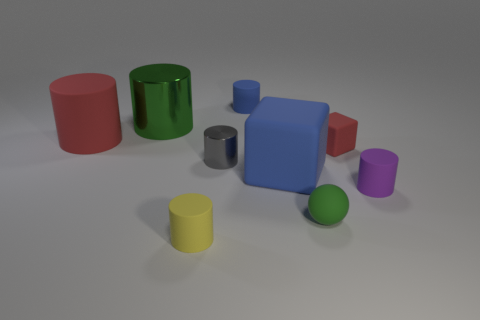How many purple things are made of the same material as the large blue thing?
Make the answer very short. 1. There is a large metal cylinder; does it have the same color as the small cylinder in front of the green rubber object?
Your answer should be very brief. No. What number of small balls are there?
Your answer should be compact. 1. Is there a large shiny object of the same color as the tiny ball?
Your response must be concise. Yes. What color is the big rubber thing that is behind the matte cube on the right side of the blue matte cube to the right of the gray thing?
Offer a terse response. Red. Does the tiny sphere have the same material as the green thing that is behind the small red cube?
Keep it short and to the point. No. What is the material of the small purple thing?
Your answer should be compact. Rubber. What is the material of the cylinder that is the same color as the matte ball?
Your answer should be compact. Metal. What number of other things are made of the same material as the red cube?
Your response must be concise. 6. There is a object that is to the right of the tiny matte ball and behind the gray metallic object; what is its shape?
Your answer should be very brief. Cube. 